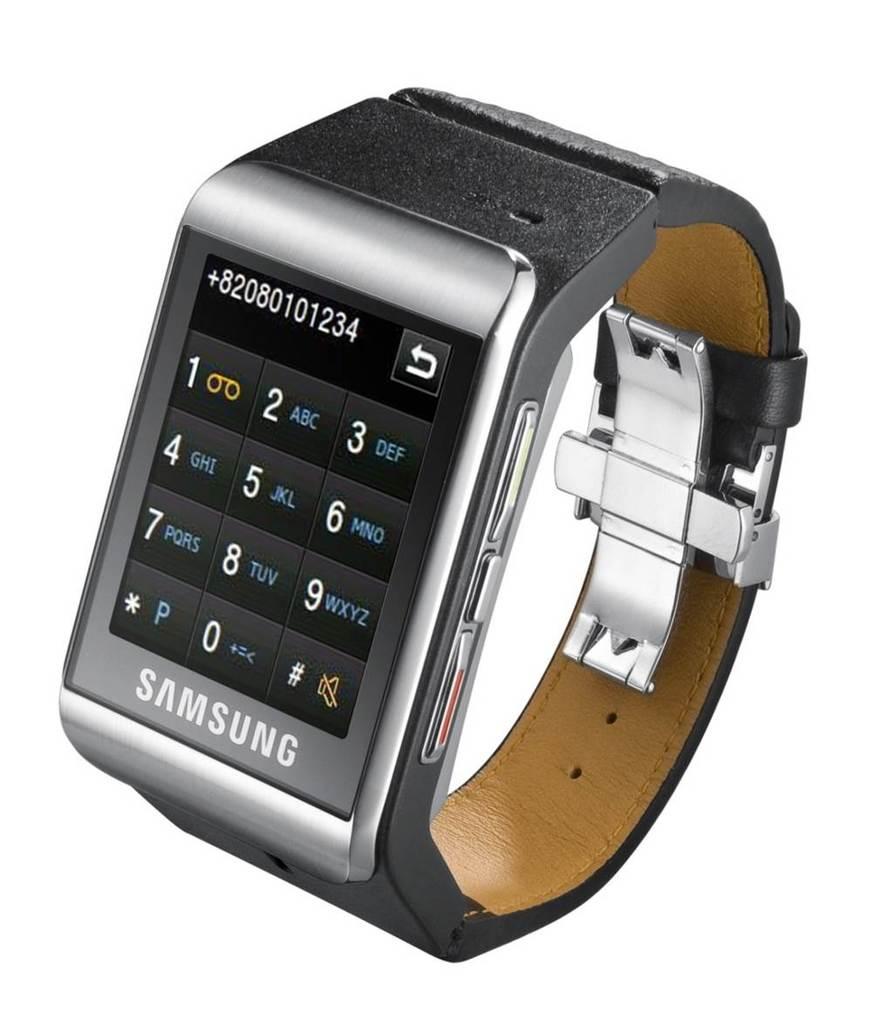What brand is this watch?
Offer a terse response. Samsung. 